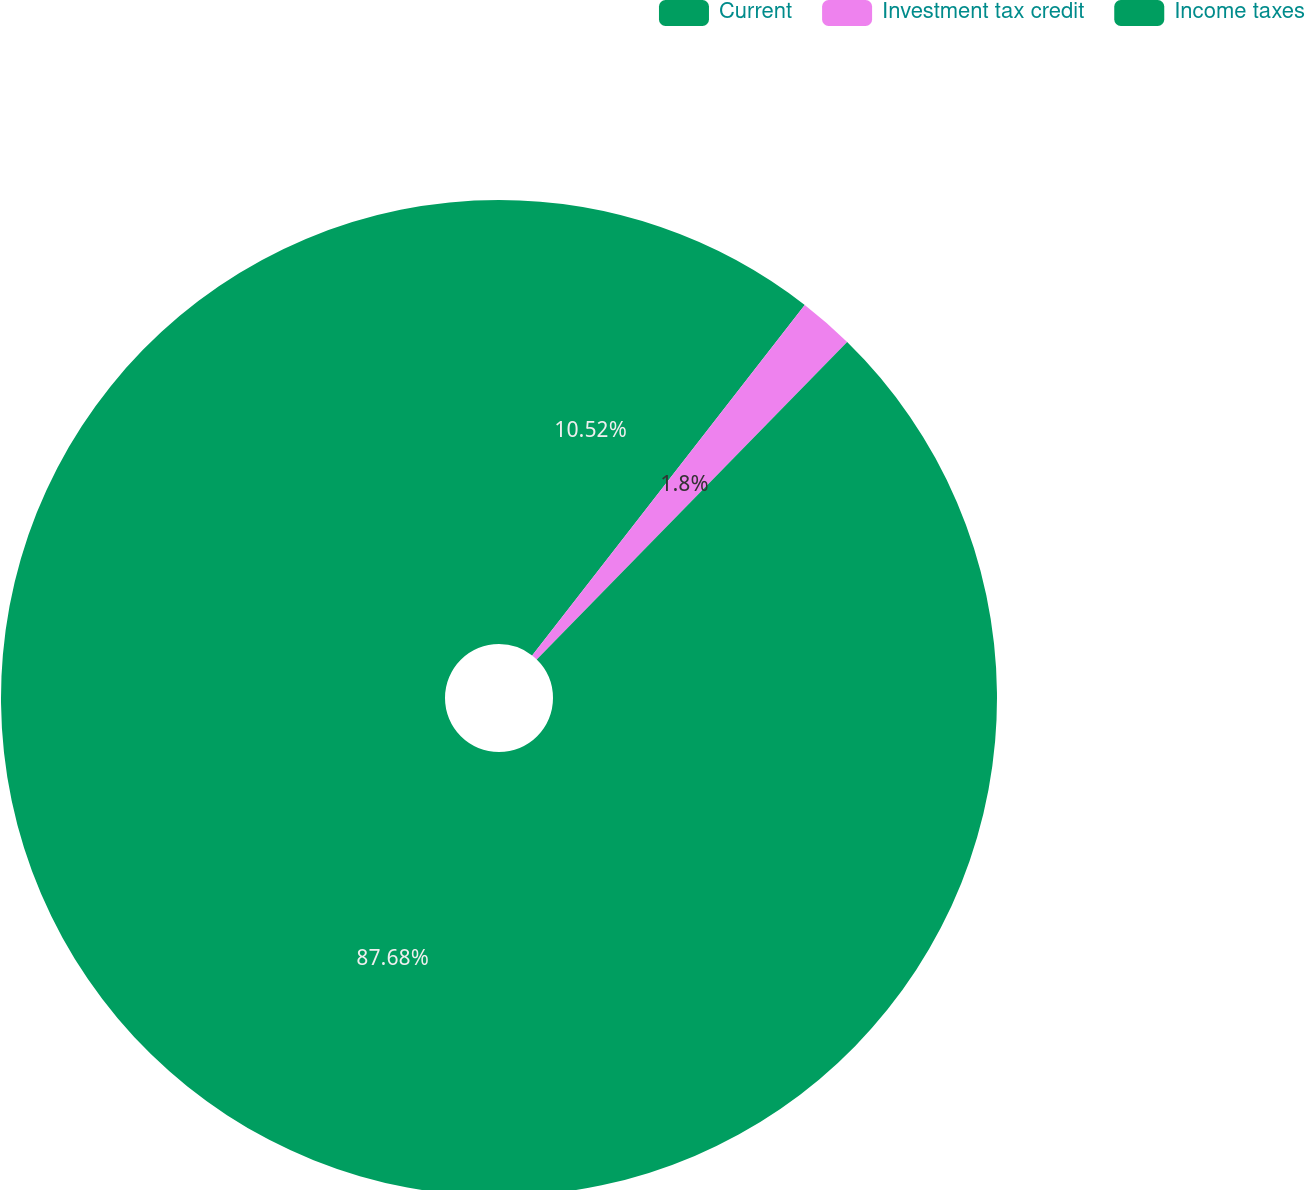Convert chart. <chart><loc_0><loc_0><loc_500><loc_500><pie_chart><fcel>Current<fcel>Investment tax credit<fcel>Income taxes<nl><fcel>10.52%<fcel>1.8%<fcel>87.67%<nl></chart> 